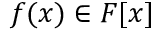<formula> <loc_0><loc_0><loc_500><loc_500>f ( x ) \in F [ x ]</formula> 